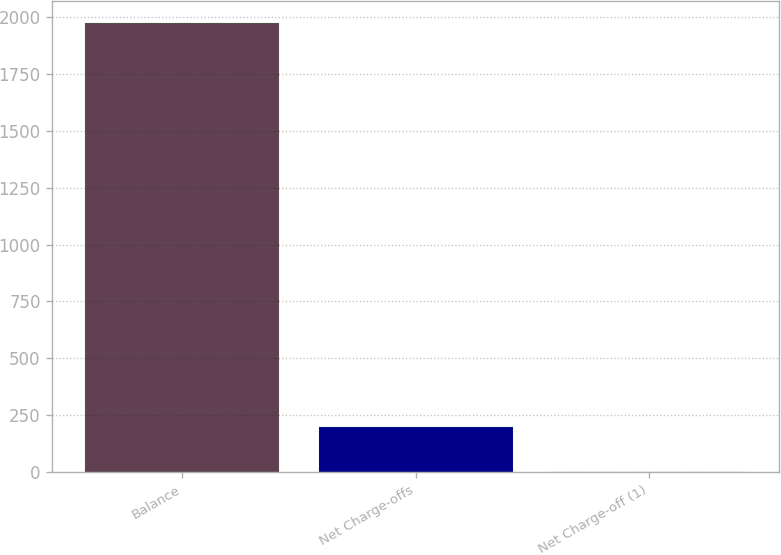Convert chart to OTSL. <chart><loc_0><loc_0><loc_500><loc_500><bar_chart><fcel>Balance<fcel>Net Charge-offs<fcel>Net Charge-off (1)<nl><fcel>1973<fcel>199.29<fcel>2.21<nl></chart> 